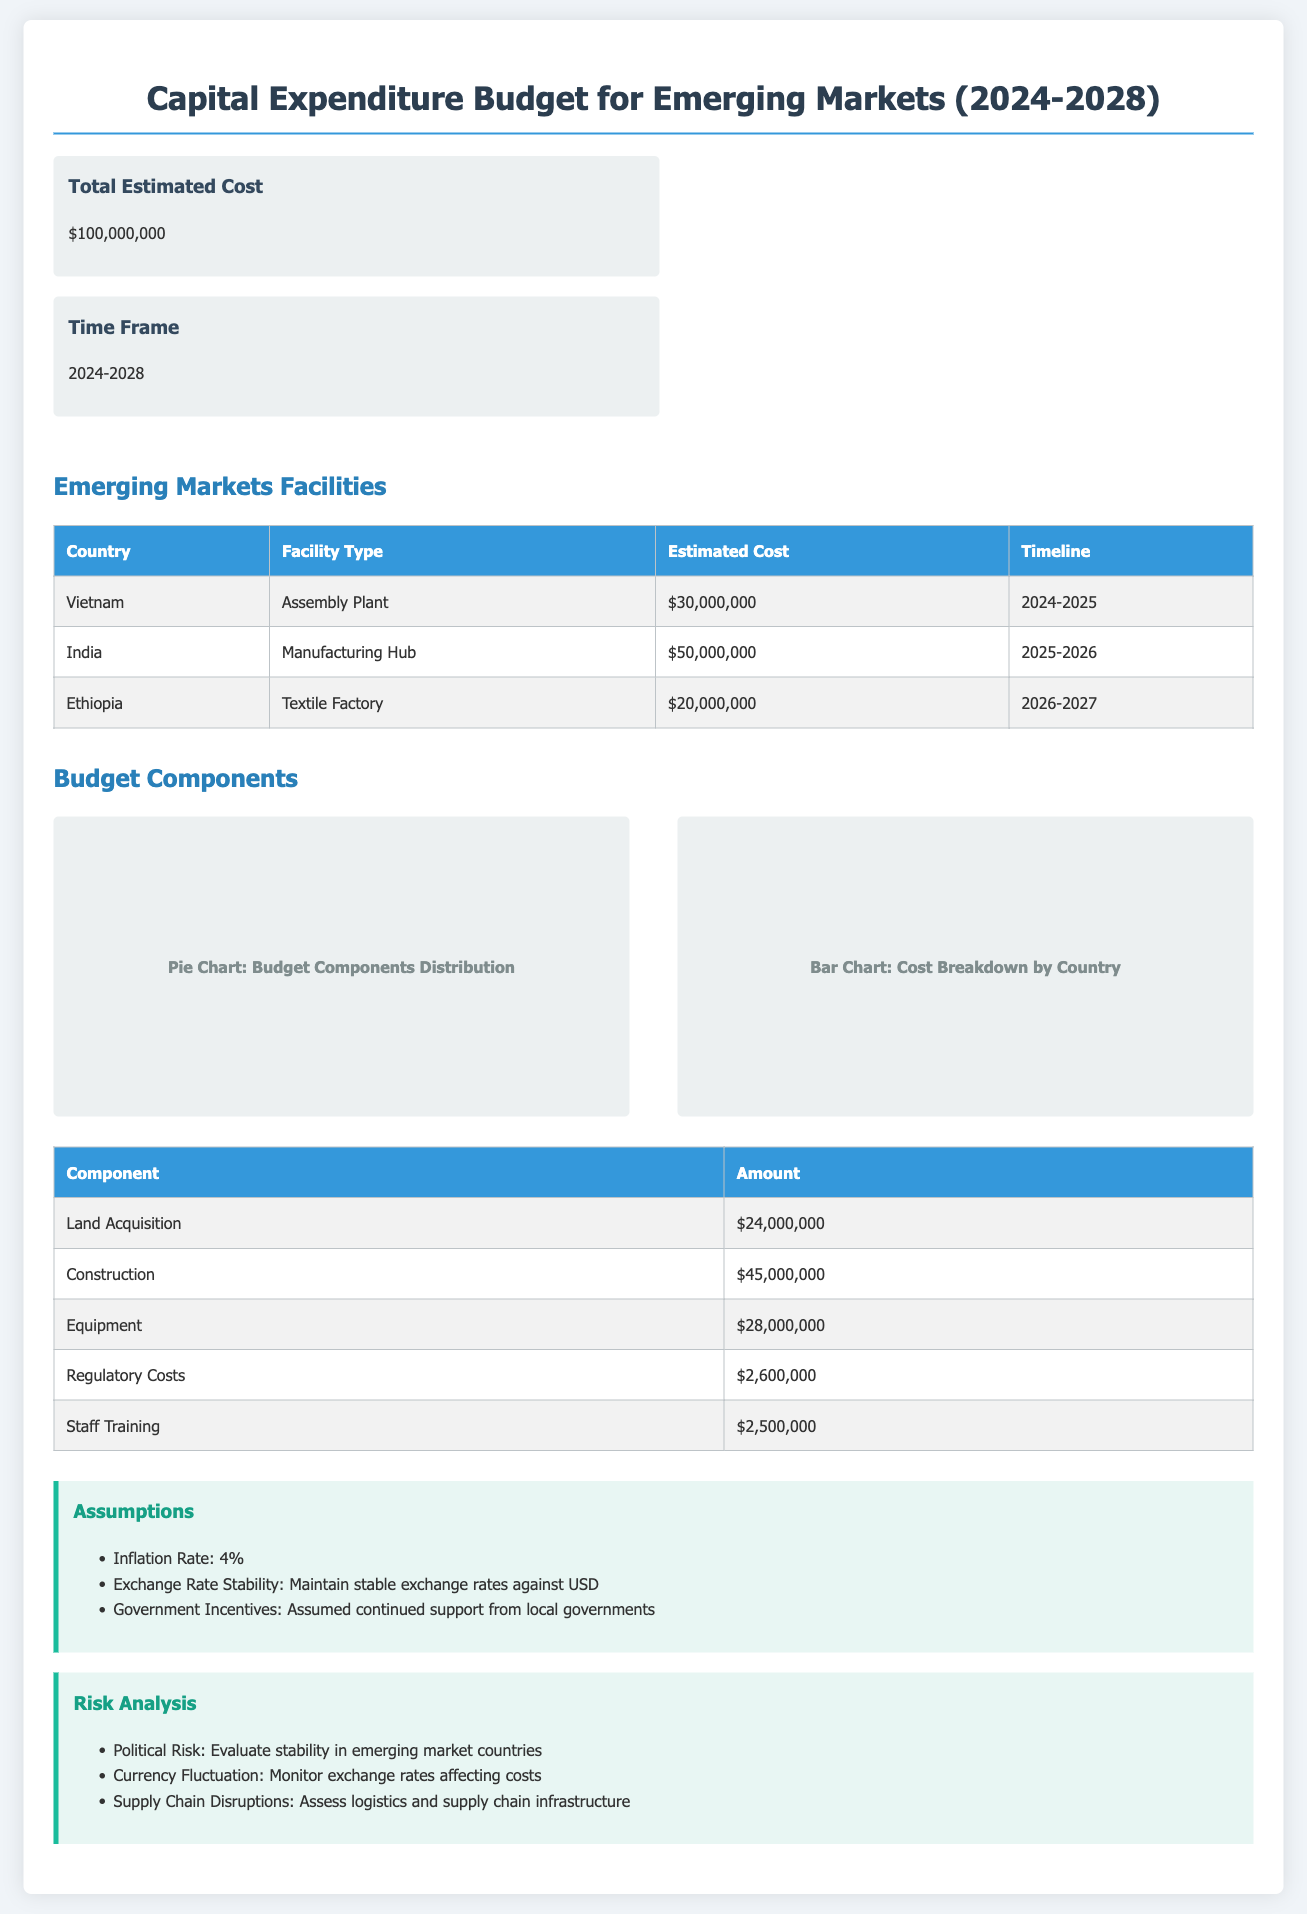what is the total estimated cost? The total estimated cost is explicitly stated in the document as $100,000,000.
Answer: $100,000,000 what are the countries mentioned in the facilities section? The countries listed for new facilities are Vietnam, India, and Ethiopia.
Answer: Vietnam, India, Ethiopia how much is allocated for the manufacturing hub in India? The estimated cost for the manufacturing hub in India is specified as $50,000,000.
Answer: $50,000,000 what is the timeline for the assembly plant in Vietnam? The assembly plant in Vietnam has a timeline set for 2024-2025.
Answer: 2024-2025 which budget component has the highest allocation? The component with the highest allocation is Construction, with an amount of $45,000,000.
Answer: Construction what is the inflation rate assumed in the budget? The document specifies an inflation rate of 4%.
Answer: 4% how much is budgeted for staff training? The budget for staff training is clearly stated as $2,500,000.
Answer: $2,500,000 what is the purpose of the risk analysis section? The risk analysis section lists potential risks that could affect the investment, such as political risk and currency fluctuation.
Answer: Potential risks what is the estimated cost for regulatory costs? The estimated cost allocated for regulatory costs is $2,600,000.
Answer: $2,600,000 what type of facility is planned for Ethiopia? The planned facility type in Ethiopia is a Textile Factory.
Answer: Textile Factory 